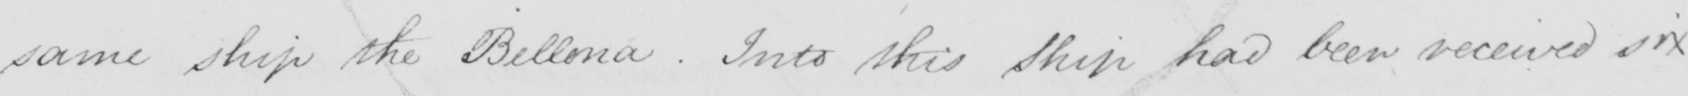What is written in this line of handwriting? same ship the Bellona . Into this ship had been received six 